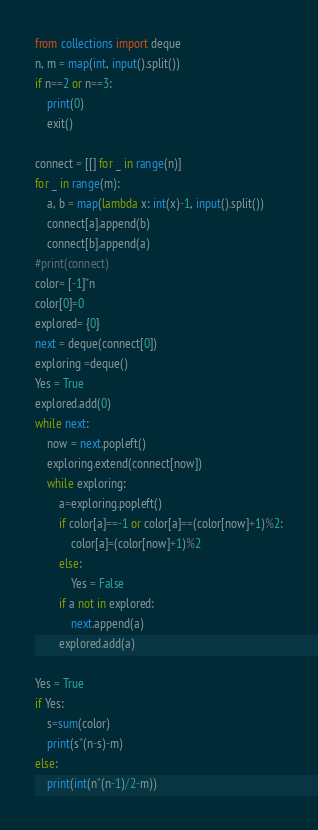<code> <loc_0><loc_0><loc_500><loc_500><_Python_>from collections import deque
n, m = map(int, input().split())
if n==2 or n==3:
    print(0)
    exit()

connect = [[] for _ in range(n)]
for _ in range(m):
    a, b = map(lambda x: int(x)-1, input().split())
    connect[a].append(b)
    connect[b].append(a)
#print(connect)
color= [-1]*n
color[0]=0
explored= {0}
next = deque(connect[0])
exploring =deque()
Yes = True
explored.add(0)
while next:
    now = next.popleft()
    exploring.extend(connect[now])
    while exploring:
        a=exploring.popleft()
        if color[a]==-1 or color[a]==(color[now]+1)%2:
            color[a]=(color[now]+1)%2
        else:
            Yes = False
        if a not in explored:
            next.append(a)
        explored.add(a)

Yes = True
if Yes:
    s=sum(color)
    print(s*(n-s)-m)
else:
    print(int(n*(n-1)/2-m))</code> 